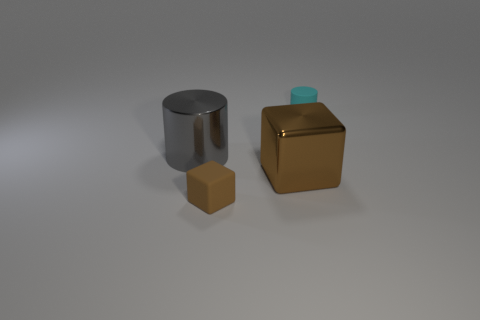Add 3 tiny brown matte objects. How many objects exist? 7 Subtract 0 red cylinders. How many objects are left? 4 Subtract all large gray cylinders. Subtract all gray metallic blocks. How many objects are left? 3 Add 4 gray cylinders. How many gray cylinders are left? 5 Add 2 small green blocks. How many small green blocks exist? 2 